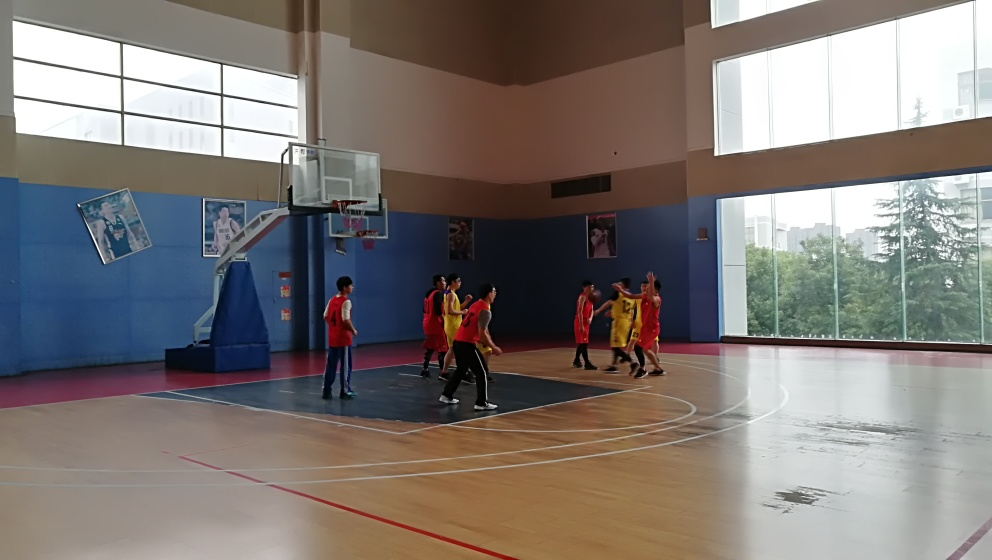Can you tell me more about the ambient lighting in this setting? Certainly! The ambient lighting in the gymnasium appears to be predominantly natural, streaming in through the tall windows along the wall. This sunlight diffuses throughout the space, casting soft shadows and providing good visibility for the basketball game without the harshness that artificial lighting might introduce. Does the natural light affect the players in any way? While direct sunlight can sometimes be a distraction or cause glare, in this particular photo it seems to enhance visibility without any negative impact. It likely creates a more pleasant playing environment for the athletes. 